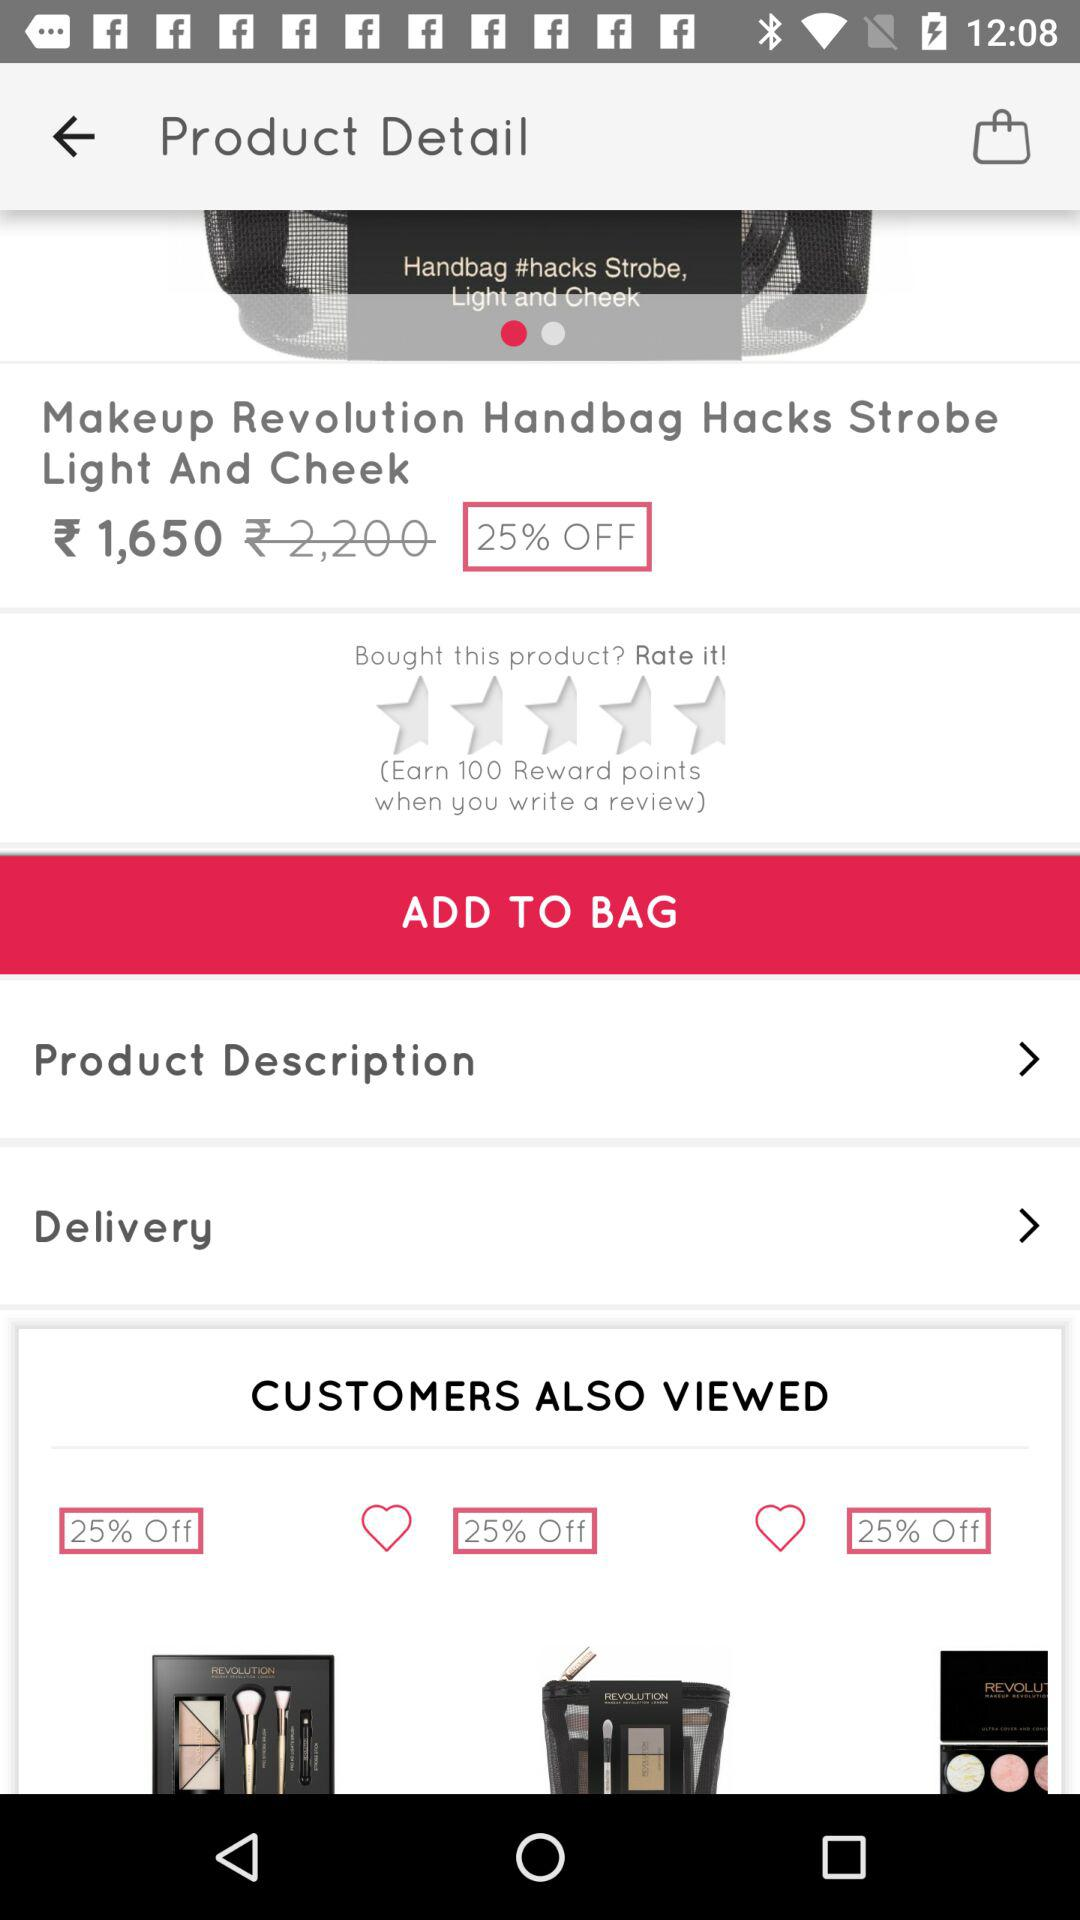How many items are there in the customers also viewed section?
Answer the question using a single word or phrase. 3 